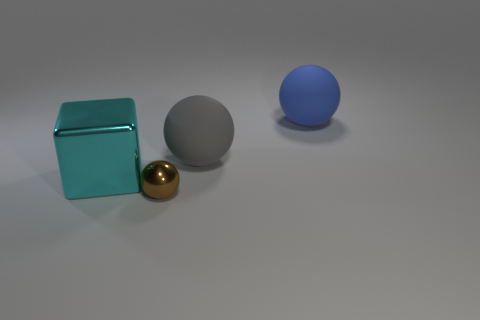Subtract all big matte spheres. How many spheres are left? 1 Add 2 large gray matte balls. How many objects exist? 6 Subtract all balls. How many objects are left? 1 Subtract all red balls. Subtract all gray cubes. How many balls are left? 3 Add 3 metal blocks. How many metal blocks are left? 4 Add 2 purple spheres. How many purple spheres exist? 2 Subtract 0 red blocks. How many objects are left? 4 Subtract all yellow cylinders. Subtract all large blue objects. How many objects are left? 3 